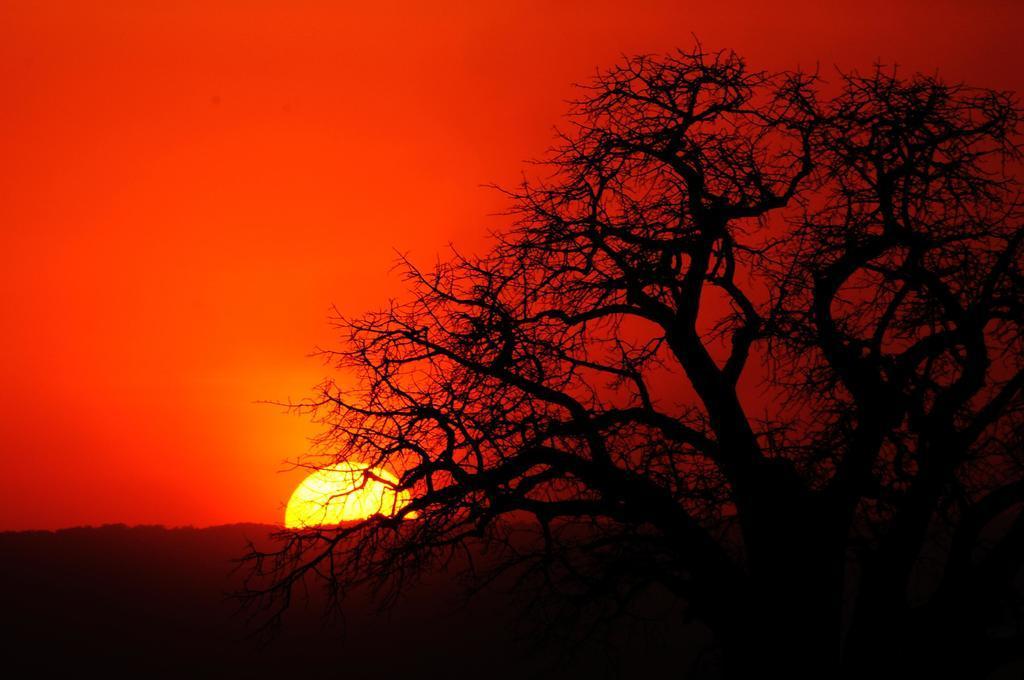In one or two sentences, can you explain what this image depicts? There is a tree on the right side of the image without leaves and there is a sun, red color sky, it seems like trees at the bottom side in the background area. 